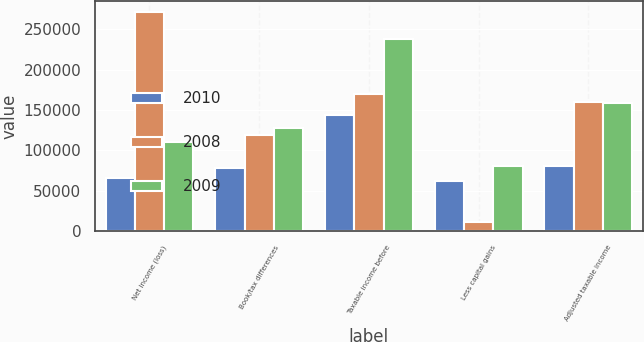Convert chart. <chart><loc_0><loc_0><loc_500><loc_500><stacked_bar_chart><ecel><fcel>Net income (loss)<fcel>Book/tax differences<fcel>Taxable income before<fcel>Less capital gains<fcel>Adjusted taxable income<nl><fcel>2010<fcel>65262<fcel>78178<fcel>143440<fcel>62477<fcel>80963<nl><fcel>2008<fcel>271490<fcel>119008<fcel>170294<fcel>10828<fcel>159466<nl><fcel>2009<fcel>110408<fcel>127607<fcel>238015<fcel>80069<fcel>157946<nl></chart> 